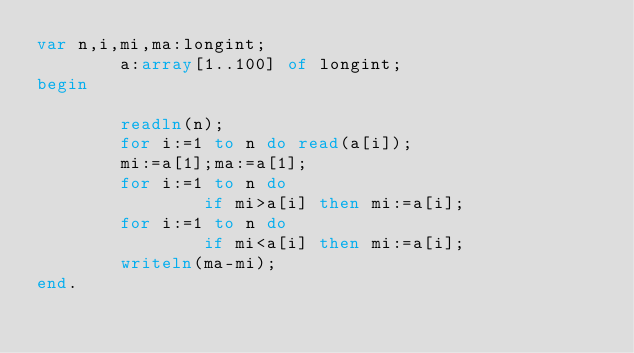Convert code to text. <code><loc_0><loc_0><loc_500><loc_500><_Pascal_>var n,i,mi,ma:longint;
        a:array[1..100] of longint;
begin

        readln(n);
        for i:=1 to n do read(a[i]);
        mi:=a[1];ma:=a[1];
        for i:=1 to n do
                if mi>a[i] then mi:=a[i];
        for i:=1 to n do
                if mi<a[i] then mi:=a[i];
        writeln(ma-mi);
end.</code> 